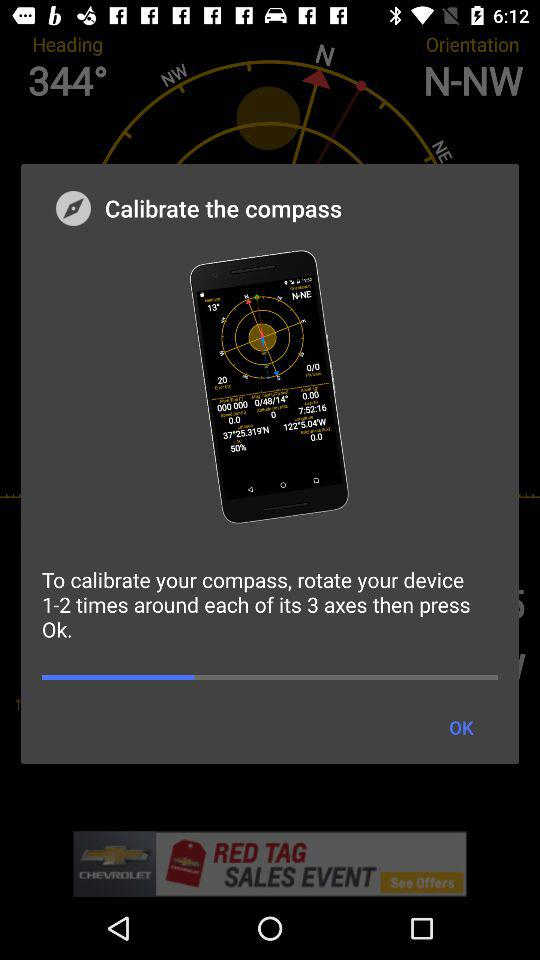How many axes does the device need to be rotated around?
Answer the question using a single word or phrase. 3 